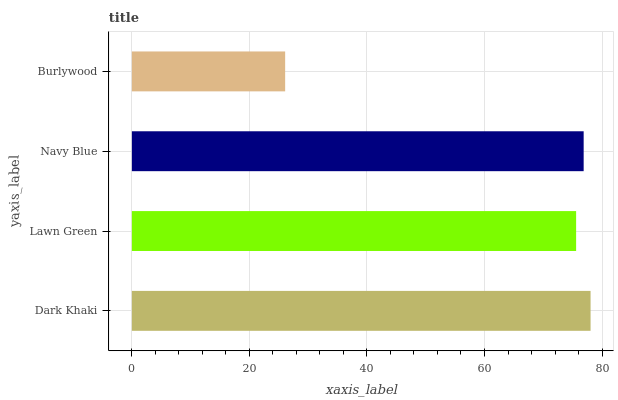Is Burlywood the minimum?
Answer yes or no. Yes. Is Dark Khaki the maximum?
Answer yes or no. Yes. Is Lawn Green the minimum?
Answer yes or no. No. Is Lawn Green the maximum?
Answer yes or no. No. Is Dark Khaki greater than Lawn Green?
Answer yes or no. Yes. Is Lawn Green less than Dark Khaki?
Answer yes or no. Yes. Is Lawn Green greater than Dark Khaki?
Answer yes or no. No. Is Dark Khaki less than Lawn Green?
Answer yes or no. No. Is Navy Blue the high median?
Answer yes or no. Yes. Is Lawn Green the low median?
Answer yes or no. Yes. Is Lawn Green the high median?
Answer yes or no. No. Is Burlywood the low median?
Answer yes or no. No. 